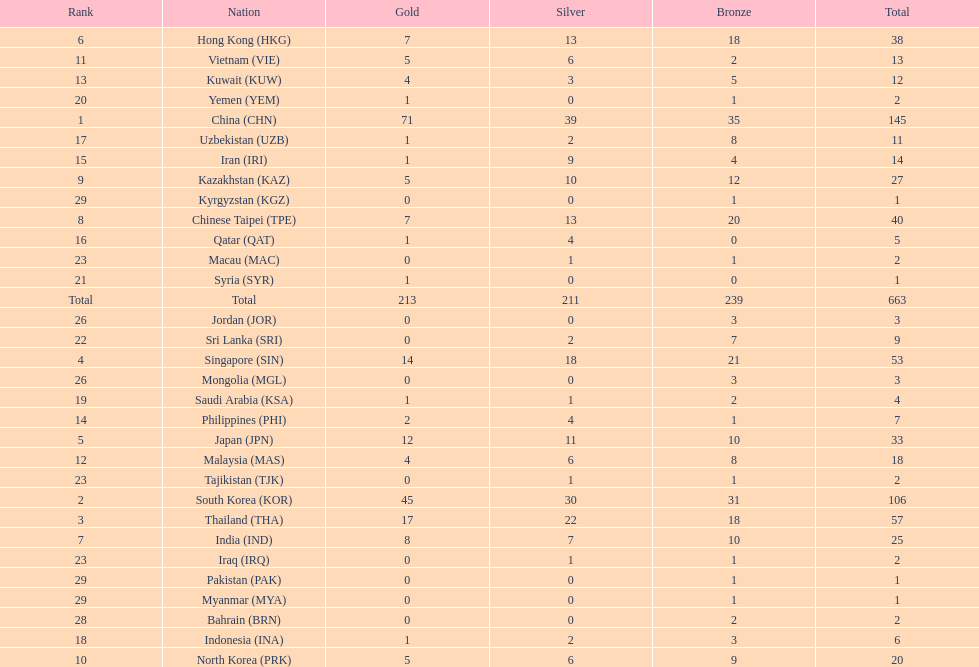Which countries have the same number of silver medals in the asian youth games as north korea? Vietnam (VIE), Malaysia (MAS). 